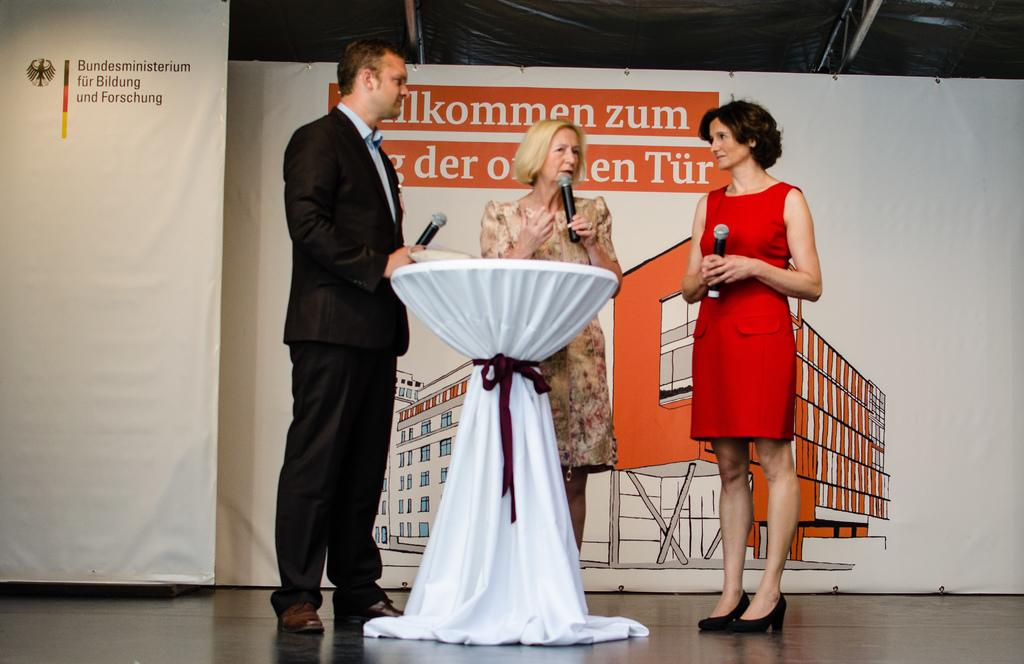How many people are in the image? There are three people in the image. What are the people doing in the image? The people are standing and holding microphones. What is in front of the people in the image? There is a table in front of the people. How many trees can be seen in the image? There are no trees visible in the image. What type of beds are present in the image? There are no beds present in the image. 